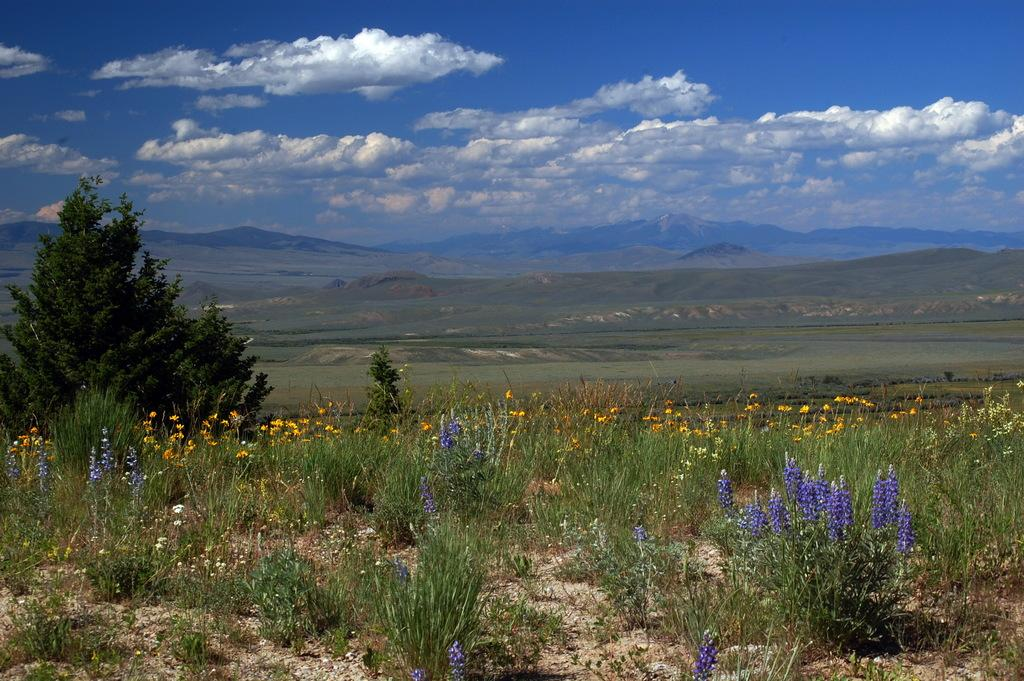What type of plants can be seen in the image? There are plants with flowers in the image. What other natural elements are present on the land? Trees are present on the land. What type of terrain is visible in the image? There is grassland visible in the image. What can be seen in the background of the image? There are hills in the background of the image. What is visible at the top of the image? The sky is visible at the top of the image. What is the condition of the sky in the image? The sky has clouds in the image. Can you tell me how many airplanes are flying over the hills in the image? There are no airplanes visible in the image; it only features plants, trees, grassland, hills, and the sky. What type of beetle can be seen crawling on the flowers in the image? There are no beetles present in the image; it only features plants with flowers. 